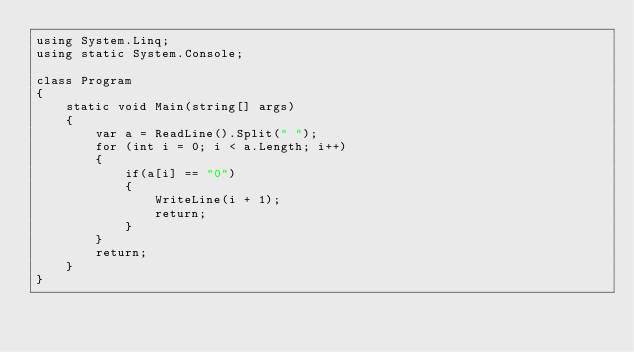Convert code to text. <code><loc_0><loc_0><loc_500><loc_500><_C#_>using System.Linq;
using static System.Console;

class Program
{
    static void Main(string[] args)
    {
        var a = ReadLine().Split(" ");
        for (int i = 0; i < a.Length; i++)
        {
            if(a[i] == "0")
            {
                WriteLine(i + 1);
                return;
            }
        }
        return;
    }
}
</code> 